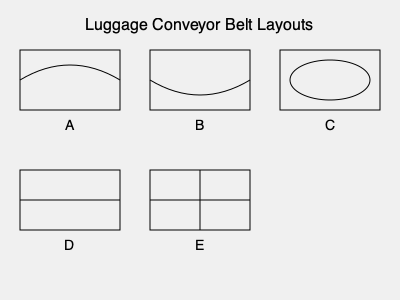As a future flight attendant, you'll need to guide passengers to the correct luggage claim area. Which of the overhead views (A, B, C, D, or E) best represents the most efficient and commonly used luggage conveyor belt layout in modern airports? To answer this question, let's analyze each layout:

1. Layout A: Shows a curved conveyor belt within a rectangular area. This design is inefficient as it wastes space and may cause luggage to bunch up on the curve.

2. Layout B: Depicts a U-shaped conveyor belt. While better than A, it still doesn't maximize space usage and may cause congestion at the turns.

3. Layout C: Illustrates an oval-shaped conveyor belt within a rectangular area. This is the most efficient and commonly used layout in modern airports because:
   - It provides a continuous flow of luggage without sharp turns.
   - Passengers can access luggage from both sides of the belt.
   - It maximizes the use of available space.
   - The oval shape allows for a larger belt length within the given area.

4. Layout D: Shows a straight conveyor belt. This design is too simplistic and doesn't provide enough belt length for luggage distribution.

5. Layout E: Represents a cross-shaped conveyor belt. This layout is impractical and would cause confusion and congestion.

The oval-shaped layout (C) is the most efficient and commonly used in modern airports, as it balances space utilization, passenger access, and smooth luggage flow.
Answer: C 